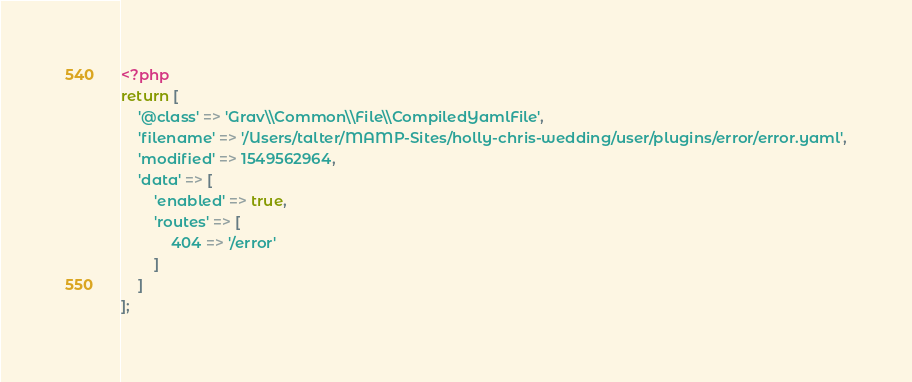<code> <loc_0><loc_0><loc_500><loc_500><_PHP_><?php
return [
    '@class' => 'Grav\\Common\\File\\CompiledYamlFile',
    'filename' => '/Users/talter/MAMP-Sites/holly-chris-wedding/user/plugins/error/error.yaml',
    'modified' => 1549562964,
    'data' => [
        'enabled' => true,
        'routes' => [
            404 => '/error'
        ]
    ]
];
</code> 